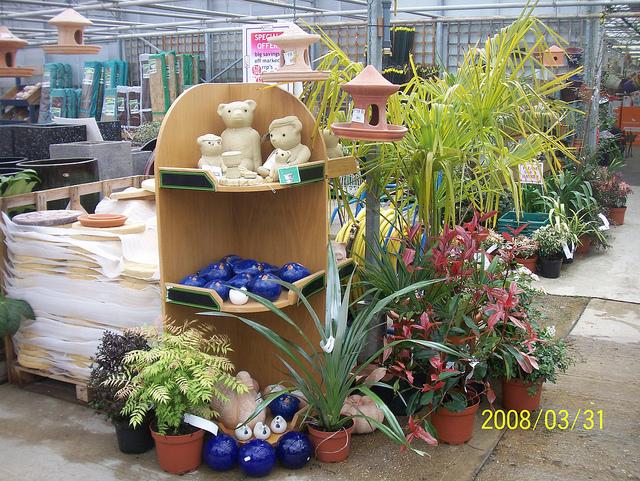Where is this?
Concise answer only. Gardening center. Where are the teddy bears?
Short answer required. Top shelf. When was this photo taken?
Keep it brief. 2008. Do you think this store sells gardening supplies?
Quick response, please. Yes. 